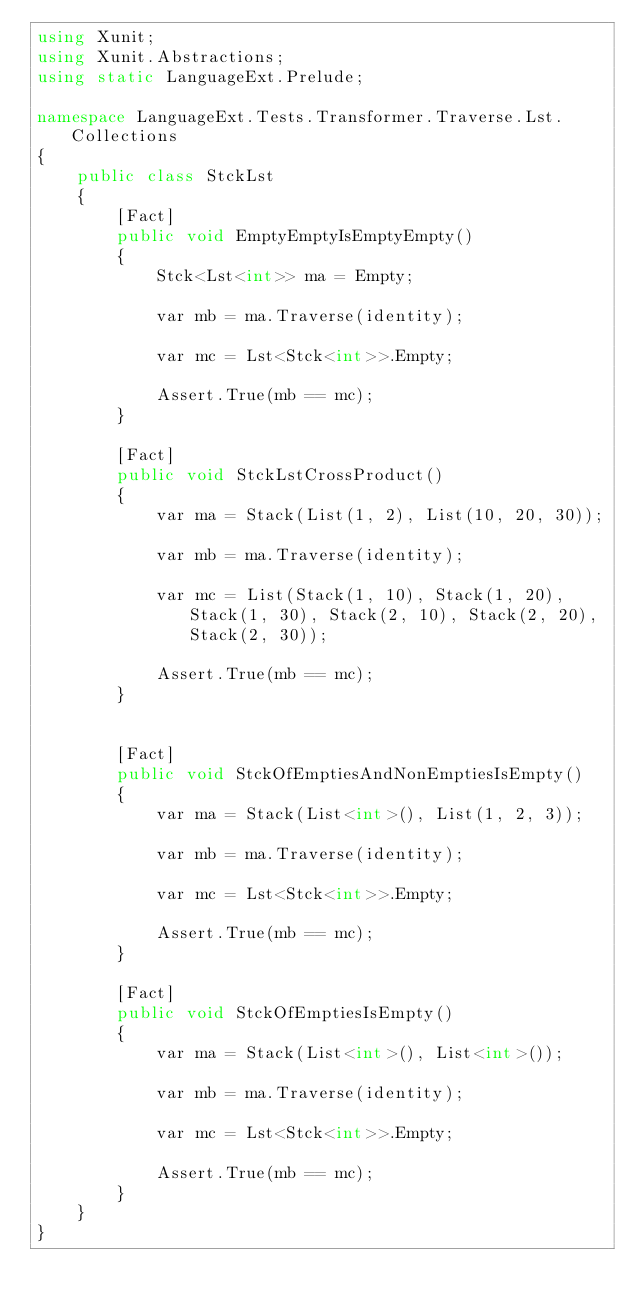Convert code to text. <code><loc_0><loc_0><loc_500><loc_500><_C#_>using Xunit;
using Xunit.Abstractions;
using static LanguageExt.Prelude;

namespace LanguageExt.Tests.Transformer.Traverse.Lst.Collections
{
    public class StckLst
    {
        [Fact]
        public void EmptyEmptyIsEmptyEmpty()
        {
            Stck<Lst<int>> ma = Empty;

            var mb = ma.Traverse(identity);

            var mc = Lst<Stck<int>>.Empty;
            
            Assert.True(mb == mc);
        }
        
        [Fact]
        public void StckLstCrossProduct()
        {
            var ma = Stack(List(1, 2), List(10, 20, 30));

            var mb = ma.Traverse(identity);

            var mc = List(Stack(1, 10), Stack(1, 20), Stack(1, 30), Stack(2, 10), Stack(2, 20), Stack(2, 30));

            Assert.True(mb == mc);
        }
        
                
        [Fact]
        public void StckOfEmptiesAndNonEmptiesIsEmpty()
        {
            var ma = Stack(List<int>(), List(1, 2, 3));

            var mb = ma.Traverse(identity);

            var mc = Lst<Stck<int>>.Empty;
            
            Assert.True(mb == mc);
        }
        
        [Fact]
        public void StckOfEmptiesIsEmpty()
        {
            var ma = Stack(List<int>(), List<int>());

            var mb = ma.Traverse(identity);

            var mc = Lst<Stck<int>>.Empty;
            
            Assert.True(mb == mc);
        }
    }
}
</code> 